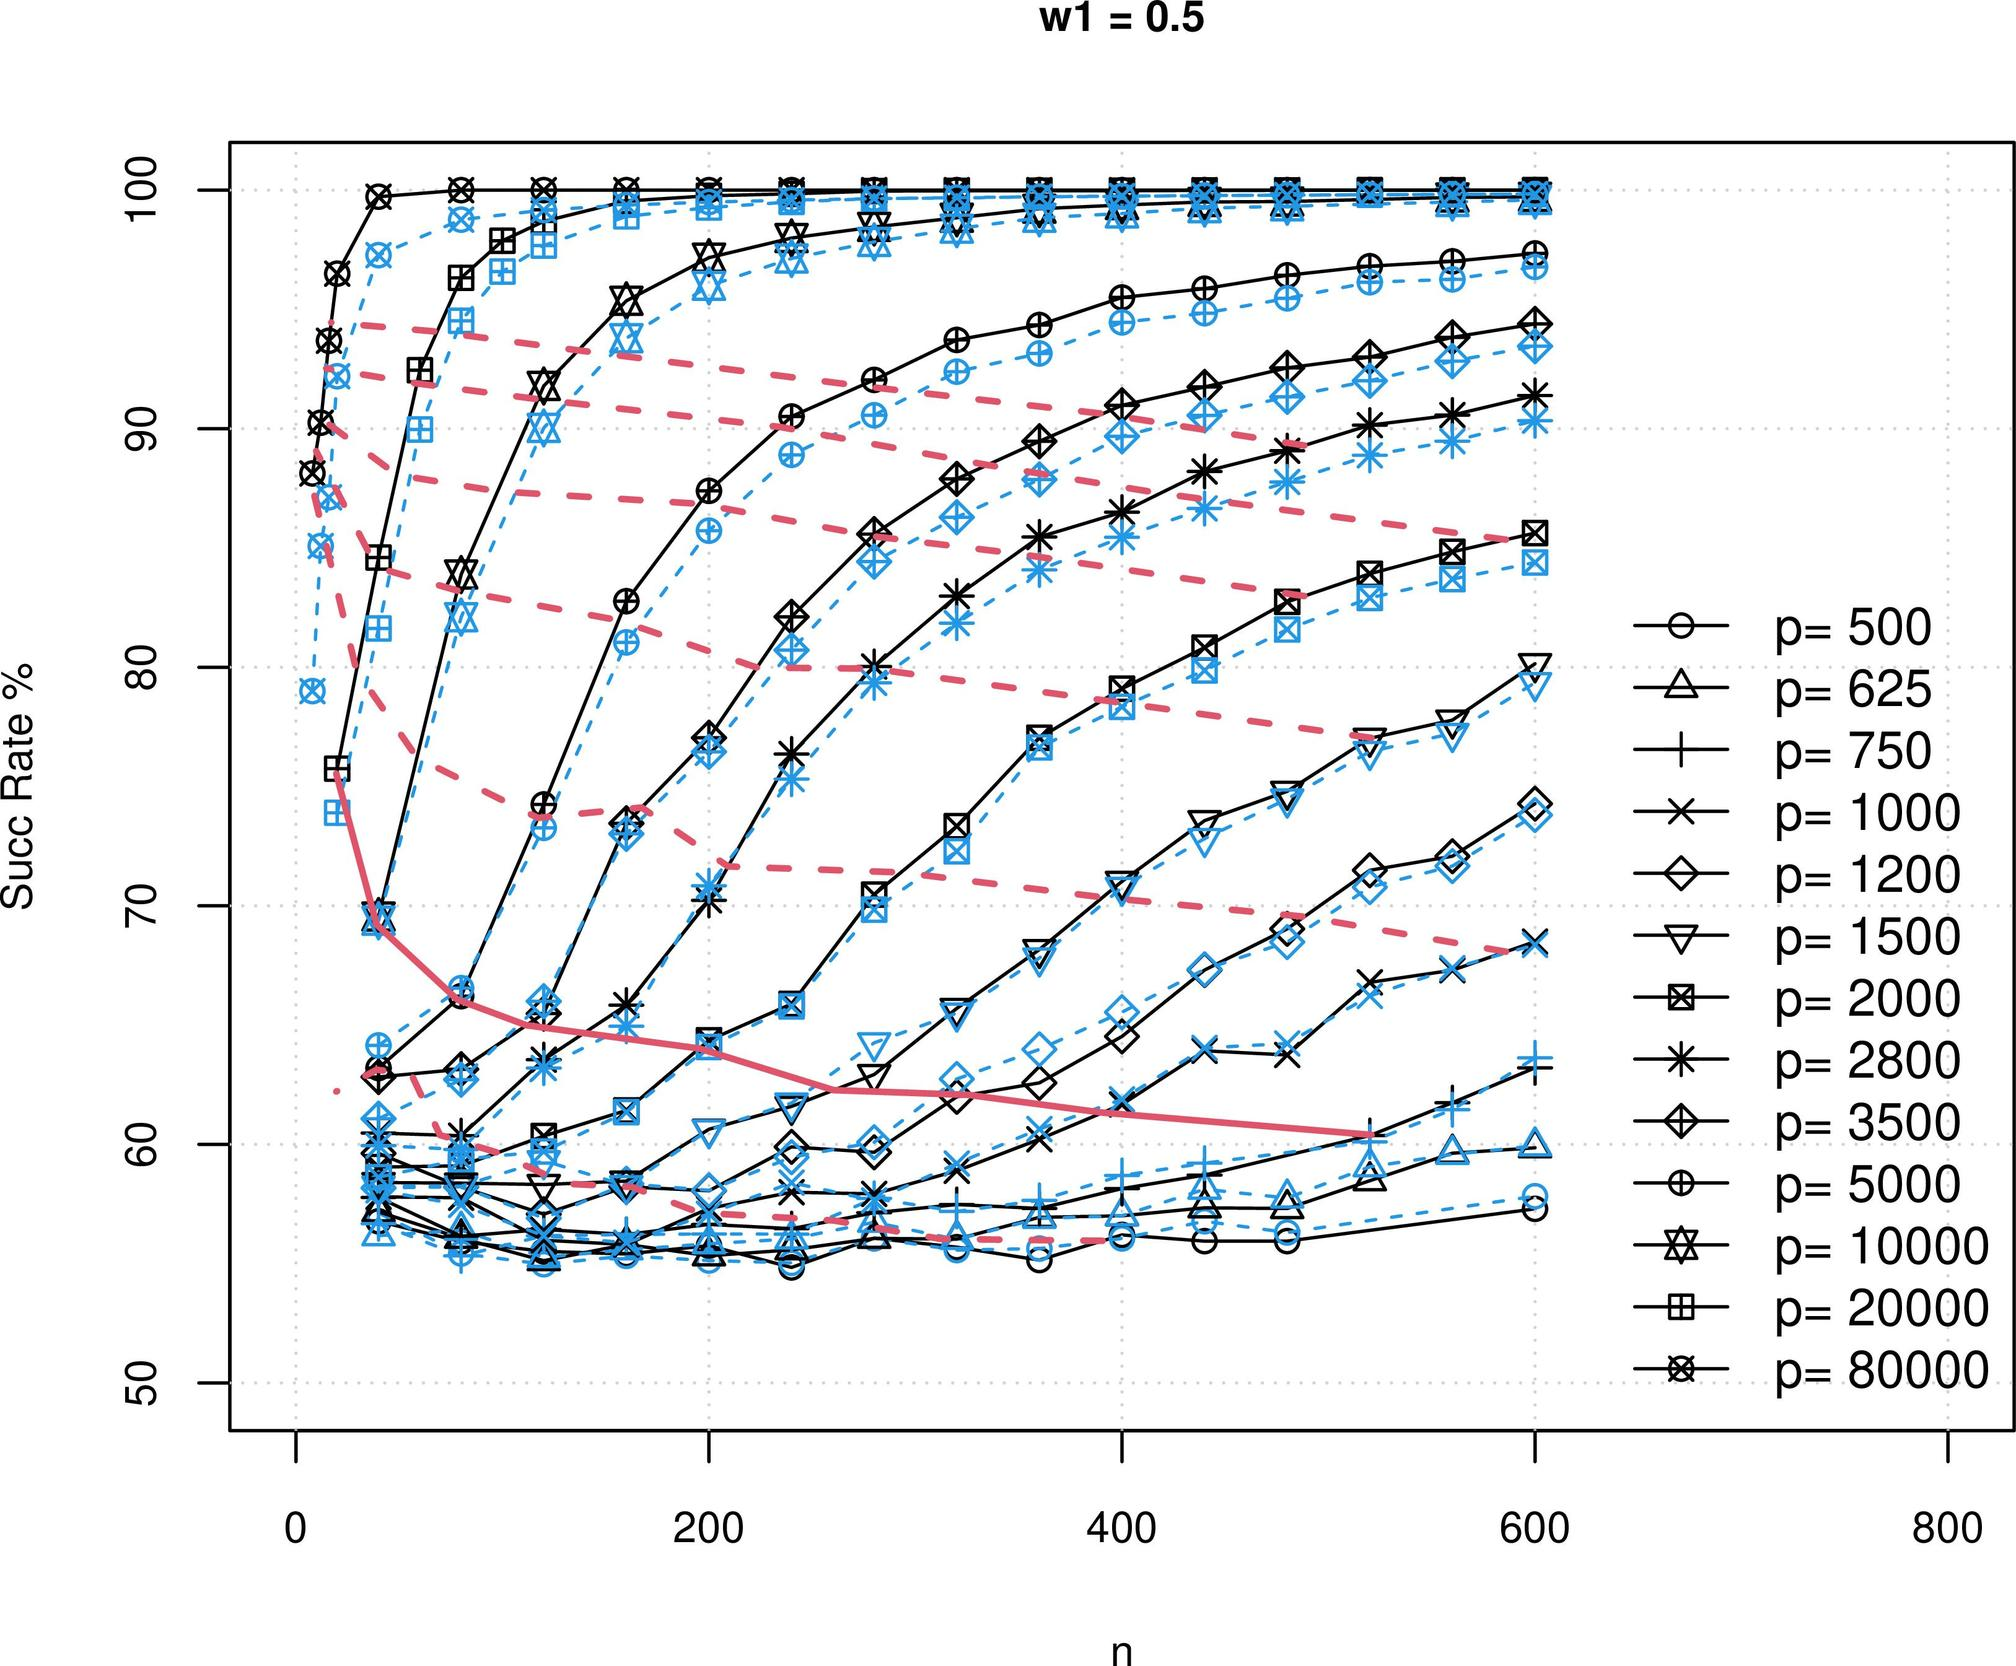Could you explain why higher 'p' values usually start at a higher success rate, even when 'n' is low? Higher initial success rates for greater 'p' values could indicate that 'p' might represent factors like resources, skill level, or other aspects that increase proficiency or capability directly from the start. As 'n' increases, these advantages might scale, allowing systems or individuals with higher 'p' to maintain or expand their lead. 